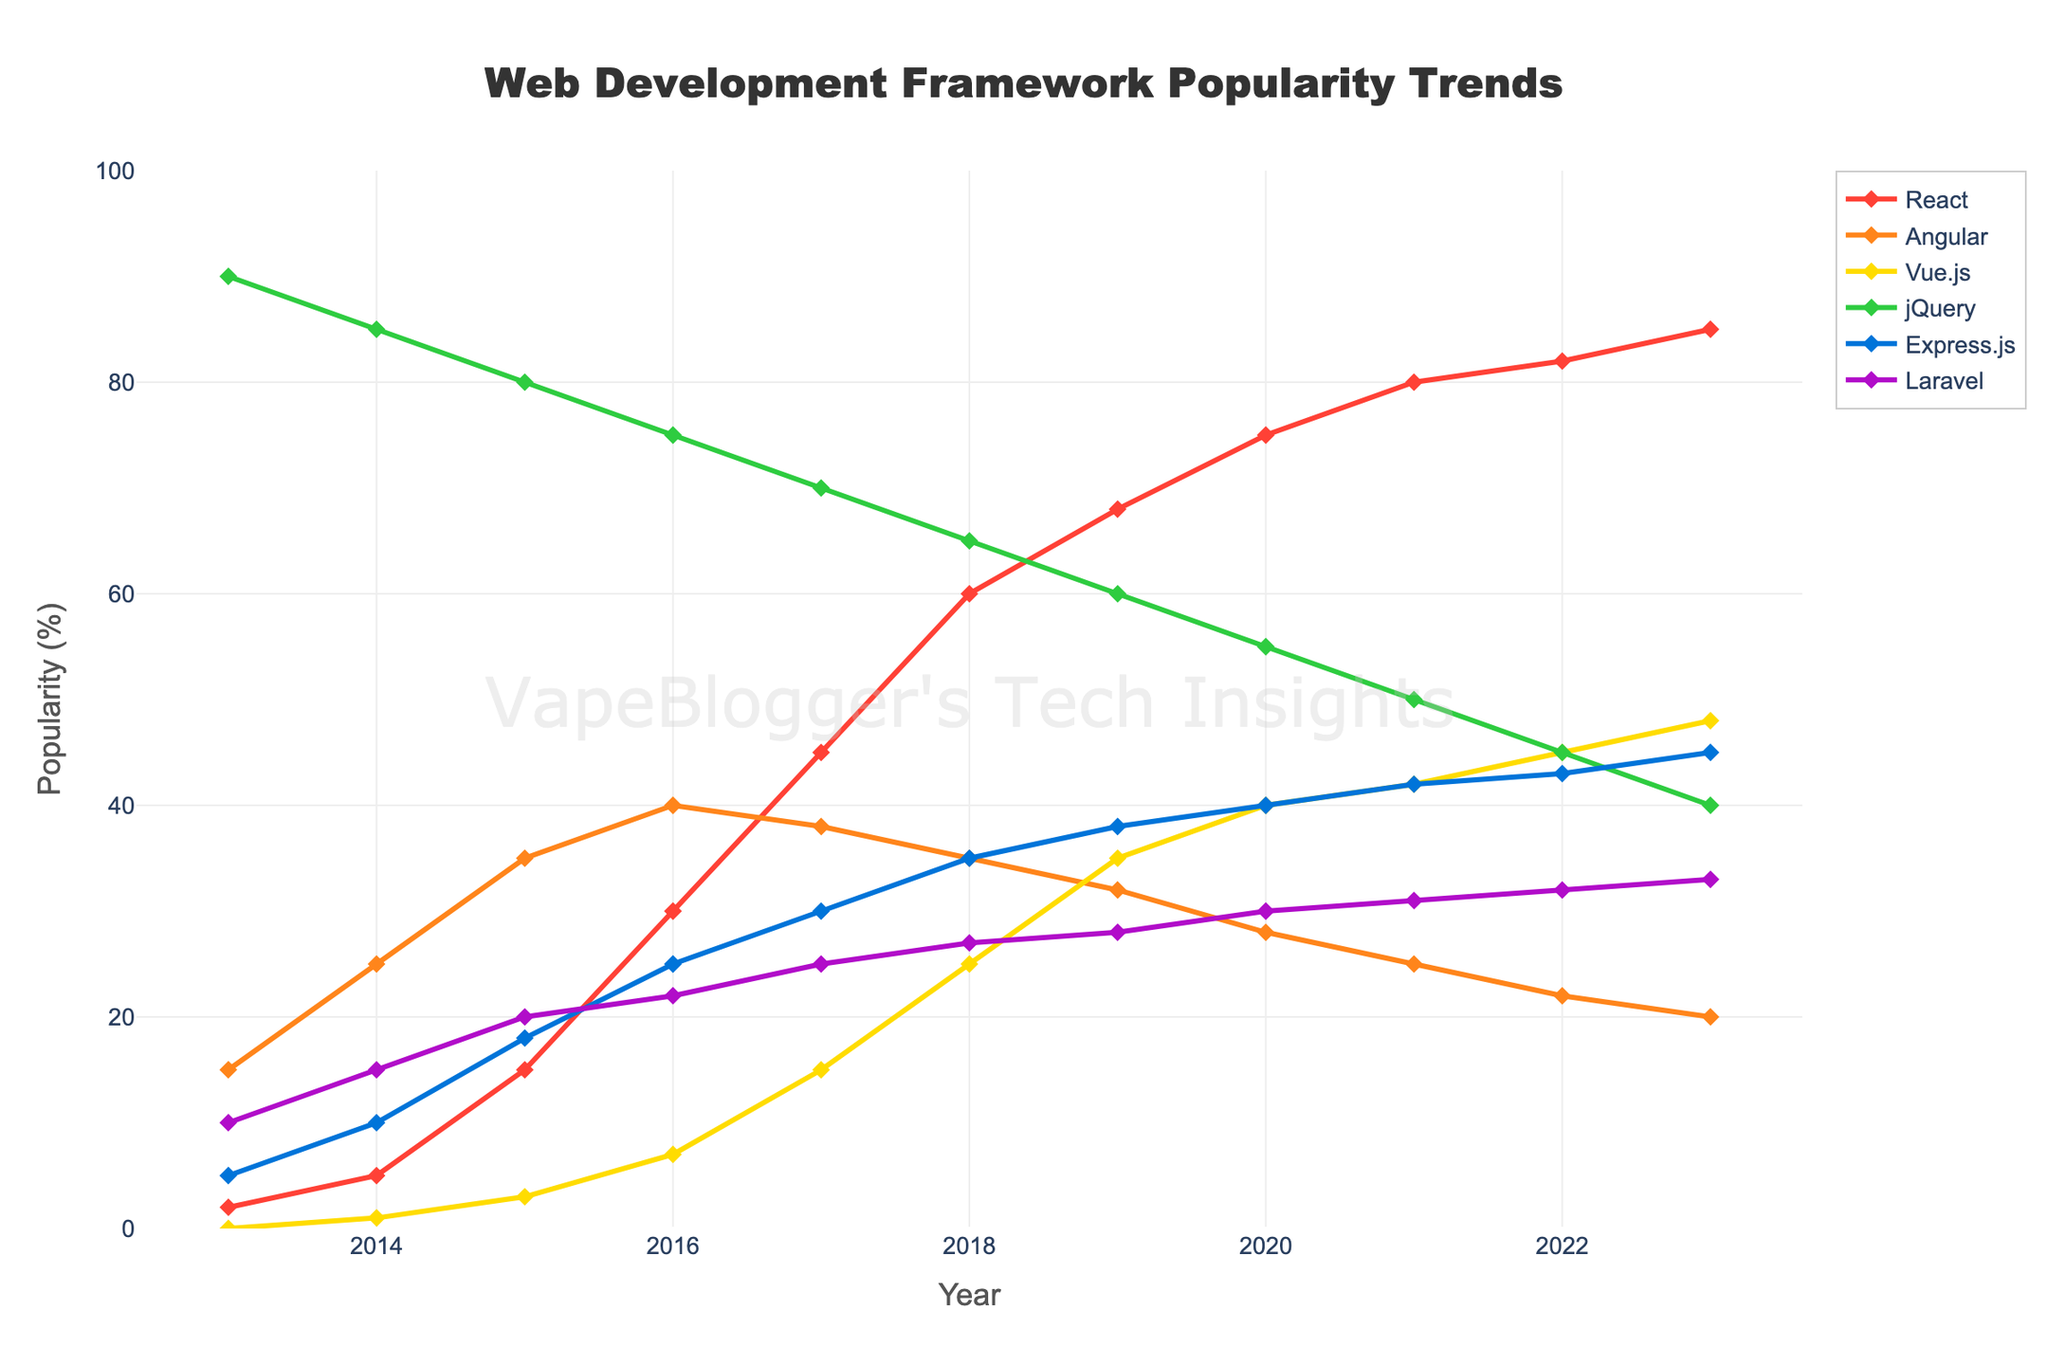What year did React become more popular than Angular? React became more popular than Angular in 2018. This can be seen by examining the intersection point of their lines on the chart, where React surpasses Angular in popularity.
Answer: 2018 Which framework had the highest popularity in 2013 and what was its popularity percentage? In 2013, jQuery was the most popular framework with a popularity percentage of 90%. This can be determined by observing the highest value on the y-axis for that year.
Answer: jQuery with 90% How much did the popularity of Vue.js increase from 2016 to 2023? The popularity of Vue.js increased from 7% in 2016 to 48% in 2023. Calculating the difference: 48% - 7% = 41%.
Answer: 41% Compare the popularity of Laravel in 2015 and 2023. By how many percentage points did it increase? In 2015, Laravel had a popularity of 20%, and in 2023, its popularity was 33%. The increase is determined by subtracting these two values: 33% - 20% = 13%.
Answer: 13% Which framework had the least variability in popularity from 2013 to 2023? jQuery had the least variability in popularity, as indicated by its relatively smooth and slowly declining line compared to other frameworks which show more significant fluctuations.
Answer: jQuery What is the average popularity of Express.js from 2013 to 2023? The popularity percentages of Express.js from 2013 to 2023 are: 5, 10, 18, 25, 30, 35, 38, 40, 42, 43, 45. Summing these values gives 331, and dividing by the number of years (11) gives an average of 30.1%.
Answer: 30.1% Which year experienced the sharpest increase in React's popularity? React experienced the sharpest increase from 2015 to 2016, where its popularity rose from 15% to 30%, a difference of 15 percentage points.
Answer: 2016 Between 2020 and 2023, which framework had the smallest change in popularity? Laravel had the smallest change in popularity between 2020 and 2023, increasing from 30% to 33%, a difference of 3 percentage points.
Answer: Laravel Is the popularity trend of Angular generally increasing, decreasing, or stable over the decade? The popularity trend of Angular is generally decreasing over the decade, as evidenced by the downward slope of its line on the graph.
Answer: Decreasing 